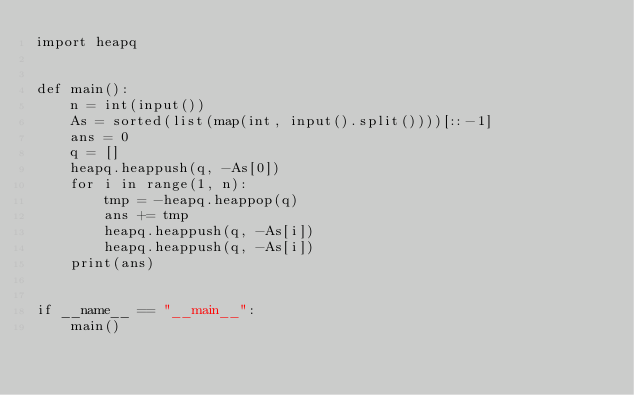<code> <loc_0><loc_0><loc_500><loc_500><_Python_>import heapq


def main():
    n = int(input())
    As = sorted(list(map(int, input().split())))[::-1]
    ans = 0
    q = []
    heapq.heappush(q, -As[0])
    for i in range(1, n):
        tmp = -heapq.heappop(q)
        ans += tmp
        heapq.heappush(q, -As[i])
        heapq.heappush(q, -As[i])
    print(ans)


if __name__ == "__main__":
    main()
</code> 